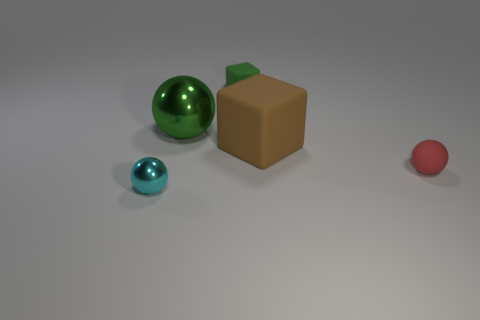What number of small rubber things are there?
Your answer should be compact. 2. What number of large objects are brown things or shiny things?
Your answer should be compact. 2. What is the shape of the brown rubber thing that is the same size as the green ball?
Give a very brief answer. Cube. Are there any other things that are the same size as the brown matte thing?
Make the answer very short. Yes. What material is the small ball that is right of the tiny ball that is in front of the rubber ball?
Your answer should be very brief. Rubber. Is the red ball the same size as the green matte thing?
Your answer should be compact. Yes. How many things are either things in front of the small red matte ball or tiny cyan rubber blocks?
Offer a very short reply. 1. What shape is the metallic object that is on the left side of the green thing that is to the left of the tiny green thing?
Your answer should be compact. Sphere. Do the green rubber thing and the metallic thing that is behind the red matte sphere have the same size?
Offer a very short reply. No. What material is the tiny ball on the right side of the brown matte cube?
Your response must be concise. Rubber. 